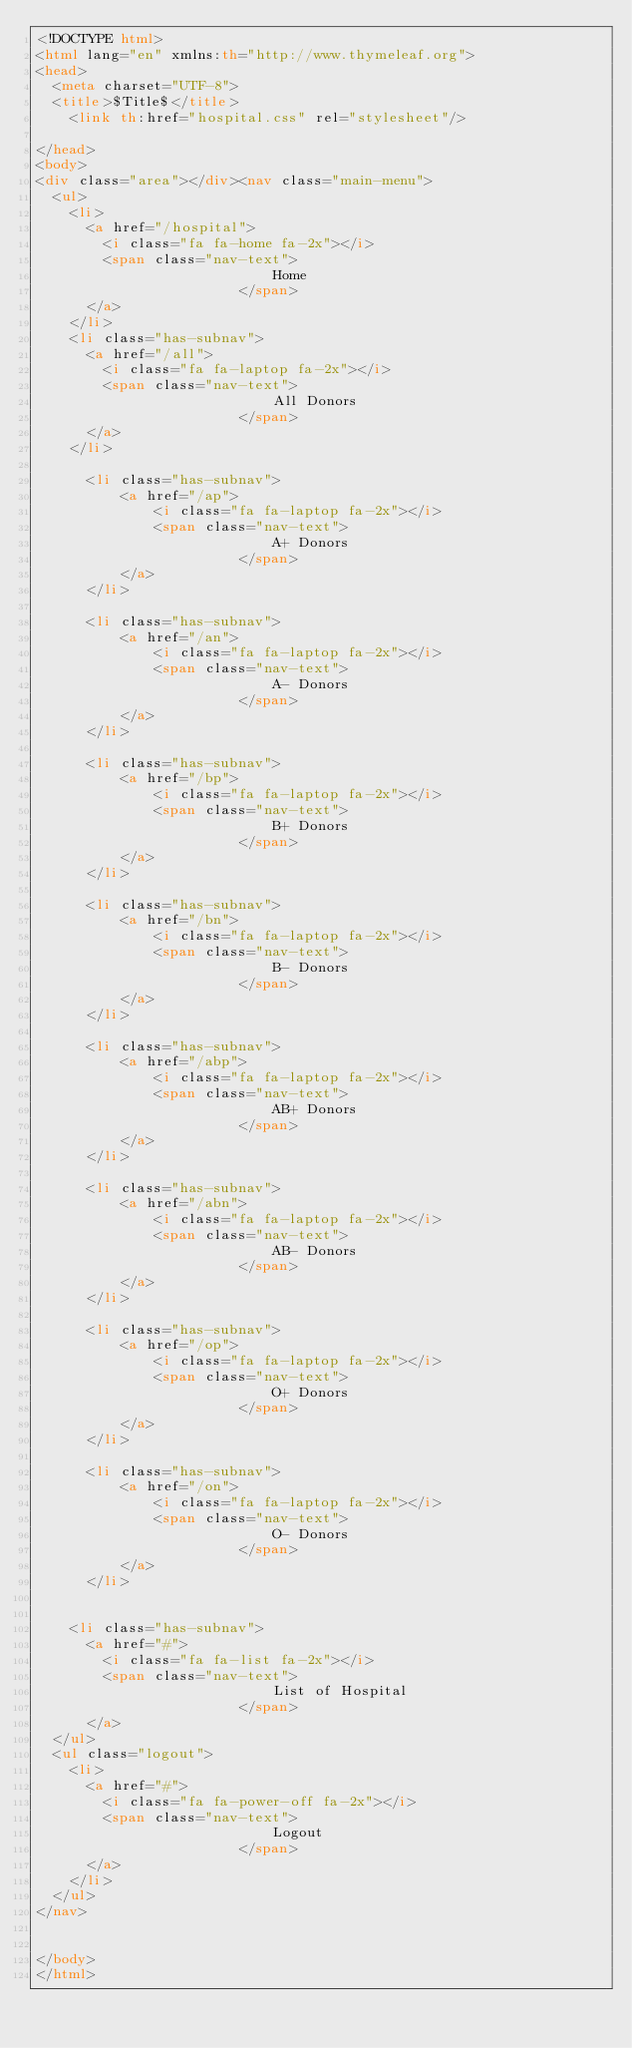Convert code to text. <code><loc_0><loc_0><loc_500><loc_500><_HTML_><!DOCTYPE html>
<html lang="en" xmlns:th="http://www.thymeleaf.org">
<head>
  <meta charset="UTF-8">
  <title>$Title$</title>
    <link th:href="hospital.css" rel="stylesheet"/>

</head>
<body>
<div class="area"></div><nav class="main-menu">
  <ul>
    <li>
      <a href="/hospital">
        <i class="fa fa-home fa-2x"></i>
        <span class="nav-text">
                            Home
                        </span>
      </a>
    </li>
    <li class="has-subnav">
      <a href="/all">
        <i class="fa fa-laptop fa-2x"></i>
        <span class="nav-text">
                            All Donors
                        </span>
      </a>
    </li>

      <li class="has-subnav">
          <a href="/ap">
              <i class="fa fa-laptop fa-2x"></i>
              <span class="nav-text">
                            A+ Donors
                        </span>
          </a>
      </li>

      <li class="has-subnav">
          <a href="/an">
              <i class="fa fa-laptop fa-2x"></i>
              <span class="nav-text">
                            A- Donors
                        </span>
          </a>
      </li>

      <li class="has-subnav">
          <a href="/bp">
              <i class="fa fa-laptop fa-2x"></i>
              <span class="nav-text">
                            B+ Donors
                        </span>
          </a>
      </li>

      <li class="has-subnav">
          <a href="/bn">
              <i class="fa fa-laptop fa-2x"></i>
              <span class="nav-text">
                            B- Donors
                        </span>
          </a>
      </li>

      <li class="has-subnav">
          <a href="/abp">
              <i class="fa fa-laptop fa-2x"></i>
              <span class="nav-text">
                            AB+ Donors
                        </span>
          </a>
      </li>

      <li class="has-subnav">
          <a href="/abn">
              <i class="fa fa-laptop fa-2x"></i>
              <span class="nav-text">
                            AB- Donors
                        </span>
          </a>
      </li>

      <li class="has-subnav">
          <a href="/op">
              <i class="fa fa-laptop fa-2x"></i>
              <span class="nav-text">
                            O+ Donors
                        </span>
          </a>
      </li>

      <li class="has-subnav">
          <a href="/on">
              <i class="fa fa-laptop fa-2x"></i>
              <span class="nav-text">
                            O- Donors
                        </span>
          </a>
      </li>


    <li class="has-subnav">
      <a href="#">
        <i class="fa fa-list fa-2x"></i>
        <span class="nav-text">
                            List of Hospital
                        </span>
      </a>
  </ul>
  <ul class="logout">
    <li>
      <a href="#">
        <i class="fa fa-power-off fa-2x"></i>
        <span class="nav-text">
                            Logout
                        </span>
      </a>
    </li>
  </ul>
</nav>


</body>
</html></code> 